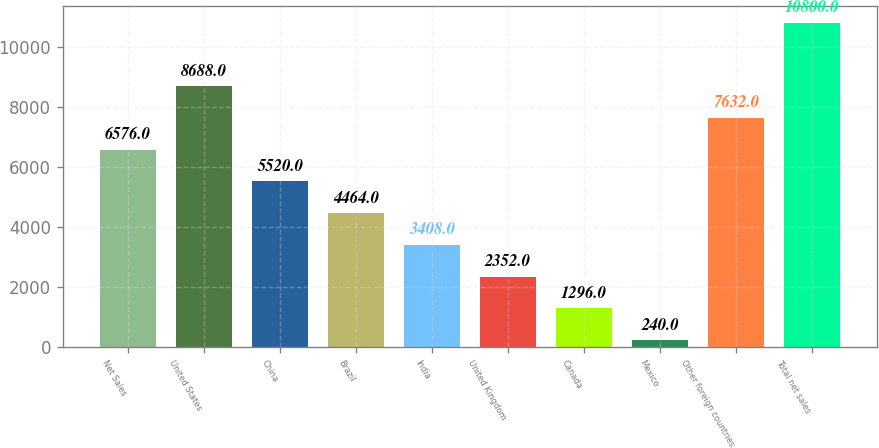Convert chart to OTSL. <chart><loc_0><loc_0><loc_500><loc_500><bar_chart><fcel>Net Sales<fcel>United States<fcel>China<fcel>Brazil<fcel>India<fcel>United Kingdom<fcel>Canada<fcel>Mexico<fcel>Other foreign countries<fcel>Total net sales<nl><fcel>6576<fcel>8688<fcel>5520<fcel>4464<fcel>3408<fcel>2352<fcel>1296<fcel>240<fcel>7632<fcel>10800<nl></chart> 